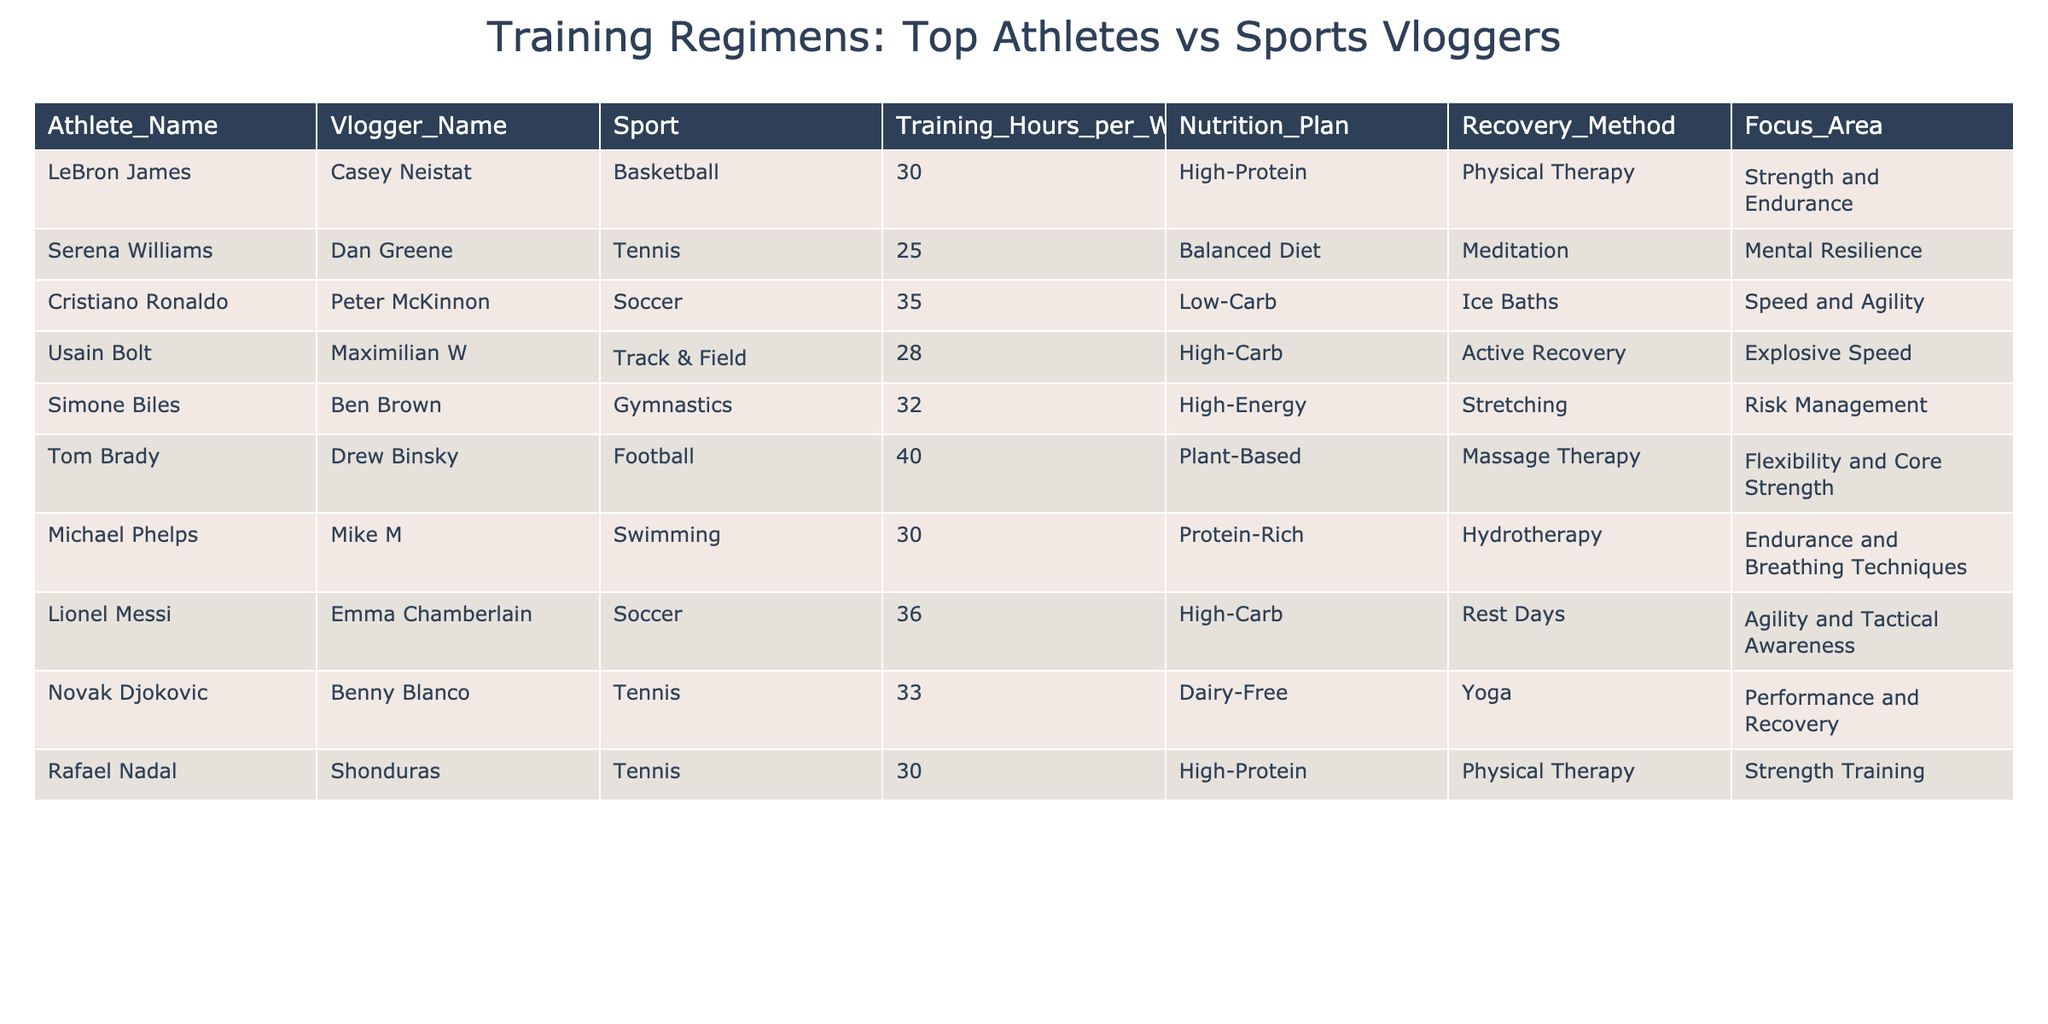What is the training hour per week for Tom Brady? From the table, we can directly find the value under the 'Training_Hours_per_Week' column corresponding to Tom Brady's name. His training hours per week are listed as 40.
Answer: 40 Which athlete has the highest training hours per week? The table shows the training hours for each athlete. By comparing the values, we see that Tom Brady has the highest at 40 hours per week.
Answer: Tom Brady Is Cristiano Ronaldo's nutrition plan high-carb? In the table, Cristiano Ronaldo's nutrition plan is listed as low-carb. Therefore, the answer is no.
Answer: No What is the average training hours per week of athletes in the table? To find the average, we sum the training hours (30 + 25 + 35 + 28 + 32 + 40 + 30 + 36 + 33 + 30) =  339 and divide by the number of athletes (10), which gives us 339/10 = 33.9.
Answer: 33.9 Which sport has the most athletes listed in the table? By reviewing the sports listed alongside each athlete, we count each sport's occurrence. Tennis has 3 athletes (Serena Williams, Novak Djokovic, Rafael Nadal), which is the highest number.
Answer: Tennis What recovery method is used by Usain Bolt? By locating Usain Bolt's entry in the table, we find that his recovery method is listed as active recovery.
Answer: Active Recovery Do any sports vloggers have a balanced diet listed in their nutrition plan? Looking at the nutrition plans of the vloggers, we see that none of them have a balanced diet listed, hence the answer is no.
Answer: No What is the difference in training hours per week between Lionel Messi and Cristiano Ronaldo? Lionel Messi has 36 hours per week, and Cristiano Ronaldo has 35. The difference is 36 - 35 = 1 hour.
Answer: 1 hour Which recovery method is most common among the athletes? By reviewing the recovery methods listed for each athlete, we see that physical therapy is used by LeBron James and Rafael Nadal. Therefore, it appears to be the most common among the entries.
Answer: Physical Therapy If Tom Brady trains 40 hours a week, what is the total training time for him over an entire month (4 weeks)? To find the total for a month, we multiply the weekly training hours by 4. So, 40 hours/week * 4 weeks = 160 hours in a month.
Answer: 160 hours 